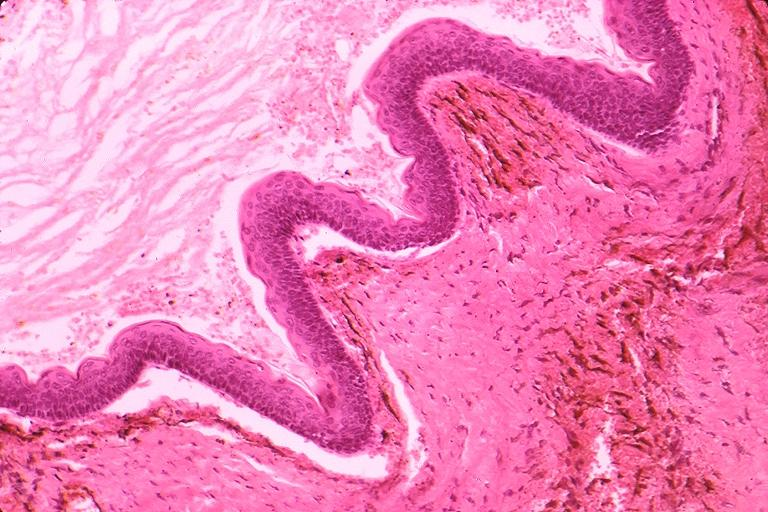does photo show odontogenic keratocyst?
Answer the question using a single word or phrase. No 